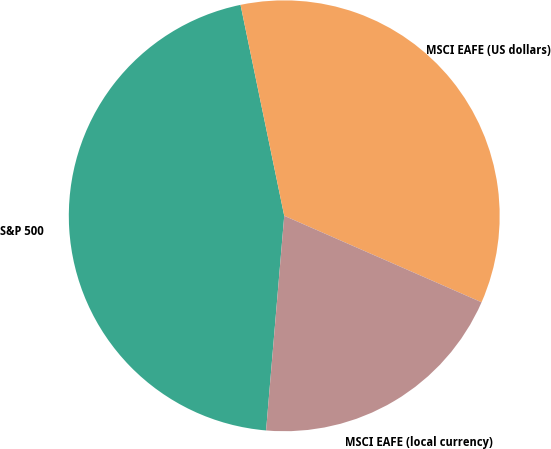Convert chart to OTSL. <chart><loc_0><loc_0><loc_500><loc_500><pie_chart><fcel>S&P 500<fcel>MSCI EAFE (US dollars)<fcel>MSCI EAFE (local currency)<nl><fcel>45.41%<fcel>34.83%<fcel>19.77%<nl></chart> 